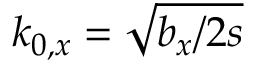Convert formula to latex. <formula><loc_0><loc_0><loc_500><loc_500>k _ { 0 , x } = \sqrt { b _ { x } / 2 s }</formula> 